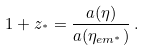Convert formula to latex. <formula><loc_0><loc_0><loc_500><loc_500>1 + z _ { ^ { * } } = \frac { a ( \eta ) } { a ( \eta _ { e m ^ { * } } ) } \, .</formula> 